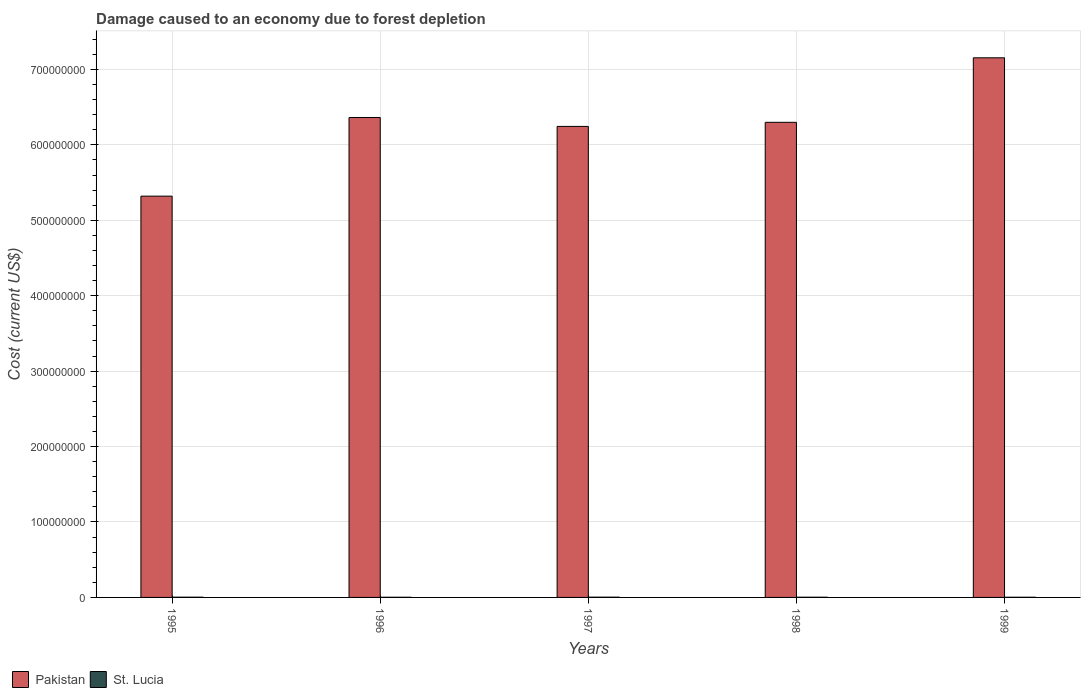How many different coloured bars are there?
Your answer should be compact. 2. How many groups of bars are there?
Provide a succinct answer. 5. How many bars are there on the 3rd tick from the left?
Make the answer very short. 2. How many bars are there on the 3rd tick from the right?
Your answer should be very brief. 2. What is the label of the 5th group of bars from the left?
Provide a short and direct response. 1999. In how many cases, is the number of bars for a given year not equal to the number of legend labels?
Make the answer very short. 0. What is the cost of damage caused due to forest depletion in St. Lucia in 1996?
Your answer should be compact. 2.29e+05. Across all years, what is the maximum cost of damage caused due to forest depletion in Pakistan?
Give a very brief answer. 7.15e+08. Across all years, what is the minimum cost of damage caused due to forest depletion in Pakistan?
Offer a terse response. 5.32e+08. In which year was the cost of damage caused due to forest depletion in St. Lucia maximum?
Offer a very short reply. 1997. What is the total cost of damage caused due to forest depletion in St. Lucia in the graph?
Make the answer very short. 1.43e+06. What is the difference between the cost of damage caused due to forest depletion in St. Lucia in 1995 and that in 1999?
Your response must be concise. 8.54e+04. What is the difference between the cost of damage caused due to forest depletion in St. Lucia in 1997 and the cost of damage caused due to forest depletion in Pakistan in 1998?
Offer a terse response. -6.30e+08. What is the average cost of damage caused due to forest depletion in St. Lucia per year?
Ensure brevity in your answer.  2.86e+05. In the year 1997, what is the difference between the cost of damage caused due to forest depletion in St. Lucia and cost of damage caused due to forest depletion in Pakistan?
Provide a succinct answer. -6.24e+08. What is the ratio of the cost of damage caused due to forest depletion in St. Lucia in 1995 to that in 1996?
Ensure brevity in your answer.  1.42. Is the cost of damage caused due to forest depletion in Pakistan in 1997 less than that in 1999?
Provide a short and direct response. Yes. What is the difference between the highest and the second highest cost of damage caused due to forest depletion in St. Lucia?
Offer a terse response. 2.09e+04. What is the difference between the highest and the lowest cost of damage caused due to forest depletion in St. Lucia?
Keep it short and to the point. 1.17e+05. In how many years, is the cost of damage caused due to forest depletion in Pakistan greater than the average cost of damage caused due to forest depletion in Pakistan taken over all years?
Provide a succinct answer. 3. What does the 1st bar from the left in 1999 represents?
Your answer should be very brief. Pakistan. What does the 2nd bar from the right in 1997 represents?
Provide a succinct answer. Pakistan. How many years are there in the graph?
Offer a very short reply. 5. What is the difference between two consecutive major ticks on the Y-axis?
Give a very brief answer. 1.00e+08. Are the values on the major ticks of Y-axis written in scientific E-notation?
Your answer should be very brief. No. Does the graph contain any zero values?
Keep it short and to the point. No. Where does the legend appear in the graph?
Make the answer very short. Bottom left. What is the title of the graph?
Offer a very short reply. Damage caused to an economy due to forest depletion. What is the label or title of the X-axis?
Provide a succinct answer. Years. What is the label or title of the Y-axis?
Keep it short and to the point. Cost (current US$). What is the Cost (current US$) in Pakistan in 1995?
Give a very brief answer. 5.32e+08. What is the Cost (current US$) of St. Lucia in 1995?
Keep it short and to the point. 3.24e+05. What is the Cost (current US$) of Pakistan in 1996?
Give a very brief answer. 6.36e+08. What is the Cost (current US$) in St. Lucia in 1996?
Your answer should be compact. 2.29e+05. What is the Cost (current US$) in Pakistan in 1997?
Keep it short and to the point. 6.24e+08. What is the Cost (current US$) in St. Lucia in 1997?
Give a very brief answer. 3.45e+05. What is the Cost (current US$) of Pakistan in 1998?
Provide a succinct answer. 6.30e+08. What is the Cost (current US$) in St. Lucia in 1998?
Make the answer very short. 2.93e+05. What is the Cost (current US$) in Pakistan in 1999?
Ensure brevity in your answer.  7.15e+08. What is the Cost (current US$) in St. Lucia in 1999?
Offer a very short reply. 2.39e+05. Across all years, what is the maximum Cost (current US$) of Pakistan?
Your response must be concise. 7.15e+08. Across all years, what is the maximum Cost (current US$) in St. Lucia?
Your response must be concise. 3.45e+05. Across all years, what is the minimum Cost (current US$) in Pakistan?
Offer a terse response. 5.32e+08. Across all years, what is the minimum Cost (current US$) of St. Lucia?
Provide a succinct answer. 2.29e+05. What is the total Cost (current US$) of Pakistan in the graph?
Your answer should be very brief. 3.14e+09. What is the total Cost (current US$) in St. Lucia in the graph?
Your response must be concise. 1.43e+06. What is the difference between the Cost (current US$) in Pakistan in 1995 and that in 1996?
Provide a short and direct response. -1.04e+08. What is the difference between the Cost (current US$) in St. Lucia in 1995 and that in 1996?
Give a very brief answer. 9.57e+04. What is the difference between the Cost (current US$) in Pakistan in 1995 and that in 1997?
Offer a very short reply. -9.24e+07. What is the difference between the Cost (current US$) of St. Lucia in 1995 and that in 1997?
Your response must be concise. -2.09e+04. What is the difference between the Cost (current US$) of Pakistan in 1995 and that in 1998?
Give a very brief answer. -9.79e+07. What is the difference between the Cost (current US$) in St. Lucia in 1995 and that in 1998?
Offer a terse response. 3.17e+04. What is the difference between the Cost (current US$) of Pakistan in 1995 and that in 1999?
Make the answer very short. -1.83e+08. What is the difference between the Cost (current US$) in St. Lucia in 1995 and that in 1999?
Provide a short and direct response. 8.54e+04. What is the difference between the Cost (current US$) of Pakistan in 1996 and that in 1997?
Keep it short and to the point. 1.18e+07. What is the difference between the Cost (current US$) of St. Lucia in 1996 and that in 1997?
Your answer should be compact. -1.17e+05. What is the difference between the Cost (current US$) of Pakistan in 1996 and that in 1998?
Your answer should be very brief. 6.40e+06. What is the difference between the Cost (current US$) of St. Lucia in 1996 and that in 1998?
Offer a very short reply. -6.39e+04. What is the difference between the Cost (current US$) in Pakistan in 1996 and that in 1999?
Keep it short and to the point. -7.91e+07. What is the difference between the Cost (current US$) in St. Lucia in 1996 and that in 1999?
Offer a terse response. -1.03e+04. What is the difference between the Cost (current US$) in Pakistan in 1997 and that in 1998?
Offer a terse response. -5.44e+06. What is the difference between the Cost (current US$) in St. Lucia in 1997 and that in 1998?
Your answer should be compact. 5.26e+04. What is the difference between the Cost (current US$) of Pakistan in 1997 and that in 1999?
Offer a terse response. -9.10e+07. What is the difference between the Cost (current US$) in St. Lucia in 1997 and that in 1999?
Make the answer very short. 1.06e+05. What is the difference between the Cost (current US$) in Pakistan in 1998 and that in 1999?
Give a very brief answer. -8.55e+07. What is the difference between the Cost (current US$) of St. Lucia in 1998 and that in 1999?
Your answer should be compact. 5.36e+04. What is the difference between the Cost (current US$) in Pakistan in 1995 and the Cost (current US$) in St. Lucia in 1996?
Offer a very short reply. 5.32e+08. What is the difference between the Cost (current US$) of Pakistan in 1995 and the Cost (current US$) of St. Lucia in 1997?
Make the answer very short. 5.32e+08. What is the difference between the Cost (current US$) in Pakistan in 1995 and the Cost (current US$) in St. Lucia in 1998?
Offer a very short reply. 5.32e+08. What is the difference between the Cost (current US$) of Pakistan in 1995 and the Cost (current US$) of St. Lucia in 1999?
Ensure brevity in your answer.  5.32e+08. What is the difference between the Cost (current US$) in Pakistan in 1996 and the Cost (current US$) in St. Lucia in 1997?
Make the answer very short. 6.36e+08. What is the difference between the Cost (current US$) of Pakistan in 1996 and the Cost (current US$) of St. Lucia in 1998?
Provide a short and direct response. 6.36e+08. What is the difference between the Cost (current US$) of Pakistan in 1996 and the Cost (current US$) of St. Lucia in 1999?
Keep it short and to the point. 6.36e+08. What is the difference between the Cost (current US$) of Pakistan in 1997 and the Cost (current US$) of St. Lucia in 1998?
Provide a succinct answer. 6.24e+08. What is the difference between the Cost (current US$) in Pakistan in 1997 and the Cost (current US$) in St. Lucia in 1999?
Make the answer very short. 6.24e+08. What is the difference between the Cost (current US$) of Pakistan in 1998 and the Cost (current US$) of St. Lucia in 1999?
Your answer should be very brief. 6.30e+08. What is the average Cost (current US$) of Pakistan per year?
Offer a very short reply. 6.28e+08. What is the average Cost (current US$) in St. Lucia per year?
Offer a very short reply. 2.86e+05. In the year 1995, what is the difference between the Cost (current US$) of Pakistan and Cost (current US$) of St. Lucia?
Give a very brief answer. 5.32e+08. In the year 1996, what is the difference between the Cost (current US$) in Pakistan and Cost (current US$) in St. Lucia?
Your answer should be very brief. 6.36e+08. In the year 1997, what is the difference between the Cost (current US$) of Pakistan and Cost (current US$) of St. Lucia?
Your response must be concise. 6.24e+08. In the year 1998, what is the difference between the Cost (current US$) of Pakistan and Cost (current US$) of St. Lucia?
Keep it short and to the point. 6.30e+08. In the year 1999, what is the difference between the Cost (current US$) of Pakistan and Cost (current US$) of St. Lucia?
Your response must be concise. 7.15e+08. What is the ratio of the Cost (current US$) in Pakistan in 1995 to that in 1996?
Make the answer very short. 0.84. What is the ratio of the Cost (current US$) in St. Lucia in 1995 to that in 1996?
Provide a succinct answer. 1.42. What is the ratio of the Cost (current US$) of Pakistan in 1995 to that in 1997?
Provide a succinct answer. 0.85. What is the ratio of the Cost (current US$) in St. Lucia in 1995 to that in 1997?
Your answer should be compact. 0.94. What is the ratio of the Cost (current US$) of Pakistan in 1995 to that in 1998?
Offer a terse response. 0.84. What is the ratio of the Cost (current US$) in St. Lucia in 1995 to that in 1998?
Give a very brief answer. 1.11. What is the ratio of the Cost (current US$) in Pakistan in 1995 to that in 1999?
Your answer should be compact. 0.74. What is the ratio of the Cost (current US$) of St. Lucia in 1995 to that in 1999?
Offer a terse response. 1.36. What is the ratio of the Cost (current US$) of Pakistan in 1996 to that in 1997?
Your answer should be very brief. 1.02. What is the ratio of the Cost (current US$) in St. Lucia in 1996 to that in 1997?
Make the answer very short. 0.66. What is the ratio of the Cost (current US$) of Pakistan in 1996 to that in 1998?
Ensure brevity in your answer.  1.01. What is the ratio of the Cost (current US$) in St. Lucia in 1996 to that in 1998?
Give a very brief answer. 0.78. What is the ratio of the Cost (current US$) of Pakistan in 1996 to that in 1999?
Make the answer very short. 0.89. What is the ratio of the Cost (current US$) of St. Lucia in 1996 to that in 1999?
Give a very brief answer. 0.96. What is the ratio of the Cost (current US$) in St. Lucia in 1997 to that in 1998?
Ensure brevity in your answer.  1.18. What is the ratio of the Cost (current US$) of Pakistan in 1997 to that in 1999?
Your response must be concise. 0.87. What is the ratio of the Cost (current US$) in St. Lucia in 1997 to that in 1999?
Offer a very short reply. 1.44. What is the ratio of the Cost (current US$) of Pakistan in 1998 to that in 1999?
Provide a succinct answer. 0.88. What is the ratio of the Cost (current US$) in St. Lucia in 1998 to that in 1999?
Provide a short and direct response. 1.22. What is the difference between the highest and the second highest Cost (current US$) of Pakistan?
Provide a succinct answer. 7.91e+07. What is the difference between the highest and the second highest Cost (current US$) in St. Lucia?
Keep it short and to the point. 2.09e+04. What is the difference between the highest and the lowest Cost (current US$) of Pakistan?
Offer a terse response. 1.83e+08. What is the difference between the highest and the lowest Cost (current US$) in St. Lucia?
Ensure brevity in your answer.  1.17e+05. 